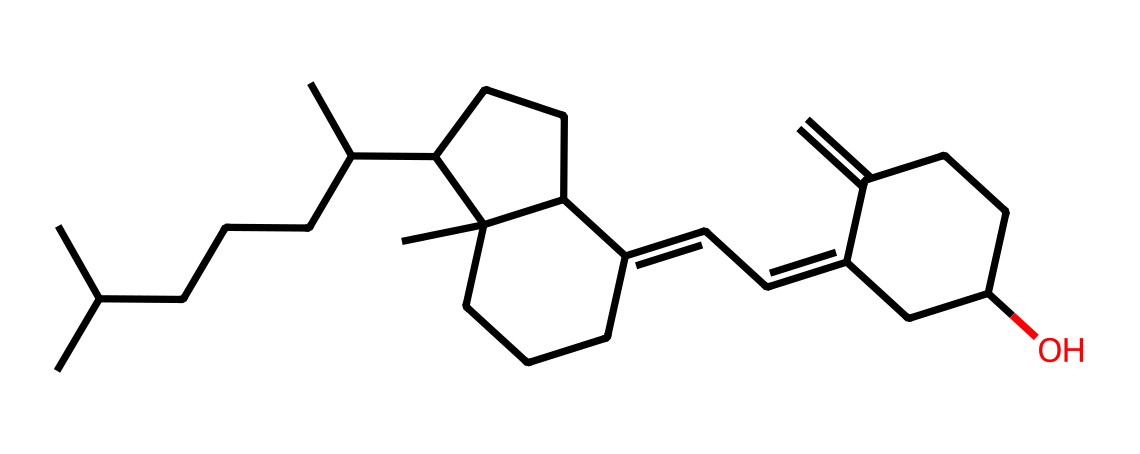How many carbon atoms are present in the structure of vitamin D3? The SMILES notation indicates a carbon-based structure where each 'C' represents a carbon atom. By counting the 'C's in the SMILES, there are 27 carbon atoms present in the structure of vitamin D3.
Answer: 27 What is the function of vitamin D3 in the human body? Vitamin D3 plays a crucial role in calcium absorption and metabolism, which is essential for maintaining bone health. This is significant for community health initiatives focused on preventing bone-related diseases.
Answer: calcium absorption Which functional groups are present in the structure of vitamin D3? The structure contains hydroxyl (OH) groups which are characteristic of alcohols. This can be determined by identifying -OH portions in the molecular structure from the SMILES representation.
Answer: hydroxyl Is vitamin D3 soluble in water? Vitamin D3 is primarily lipid-soluble due to its hydrocarbon structure, which hinders its solubility in water. This can be inferred by examining the predominant carbon and hydrogen content, leading to low polarity.
Answer: no What is the molecular weight of vitamin D3? To find the molecular weight, the atomic weights of all the constituent atoms need to be summed based on the chemical formula derived from the SMILES. For vitamin D3, the calculated molecular weight is approximately 384.65 g/mol.
Answer: 384.65 g/mol What type of molecule is vitamin D3 classified as? Vitamin D3 is classified as a secosteroid due to its steroid-like structure and the presence of a broken ring in its molecular composition. This classification can be understood from the structural characteristics indicated in the SMILES.
Answer: secosteroid What role does vitamin D3 play in disease prevention within community health? Vitamin D3 is significant in preventing osteoporosis and rickets, highlighting its importance in community health initiatives aimed at promoting overall skeletal health as well as reducing the risk of bone-related diseases.
Answer: disease prevention 